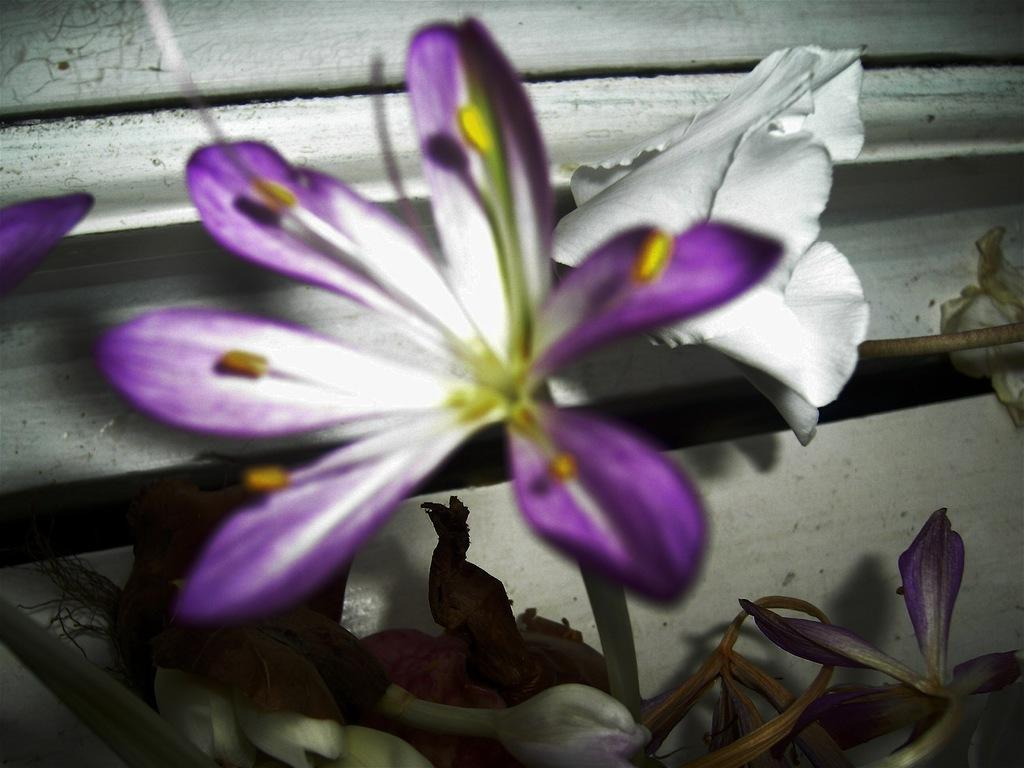What is present in the image? There are flowers in the image. What is the color of the surface on which the flowers are placed? The flowers are on a white surface. What type of behavior can be observed in the ducks in the image? There are no ducks present in the image, so their behavior cannot be observed. 